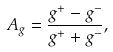Convert formula to latex. <formula><loc_0><loc_0><loc_500><loc_500>A _ { g } = \frac { g ^ { + } - g ^ { - } } { g ^ { + } + g ^ { - } } ,</formula> 